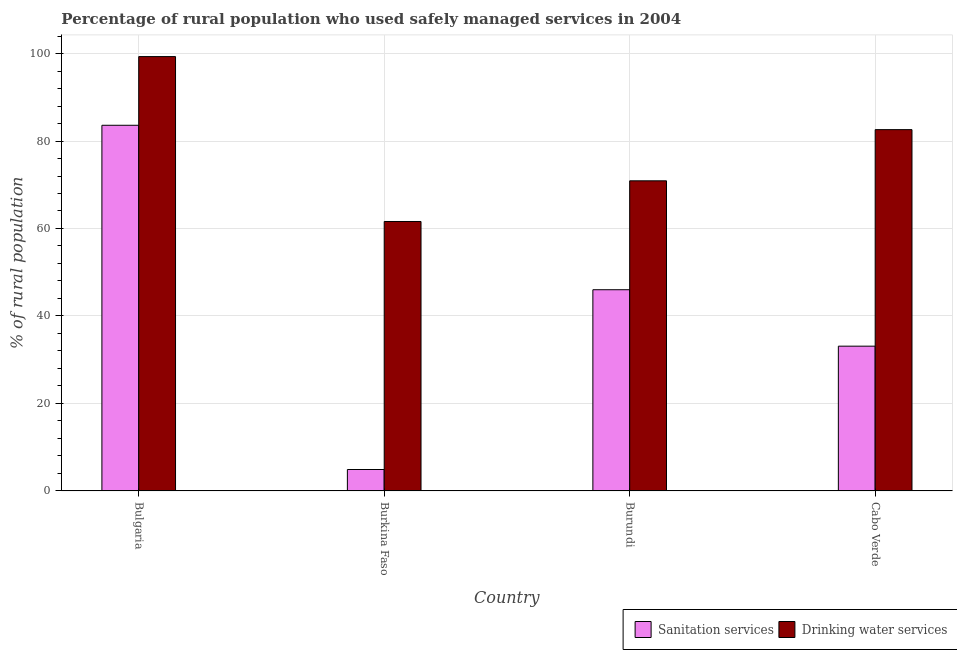How many different coloured bars are there?
Ensure brevity in your answer.  2. Are the number of bars on each tick of the X-axis equal?
Your answer should be compact. Yes. What is the label of the 3rd group of bars from the left?
Your response must be concise. Burundi. In how many cases, is the number of bars for a given country not equal to the number of legend labels?
Ensure brevity in your answer.  0. What is the percentage of rural population who used drinking water services in Bulgaria?
Keep it short and to the point. 99.3. Across all countries, what is the maximum percentage of rural population who used drinking water services?
Your response must be concise. 99.3. Across all countries, what is the minimum percentage of rural population who used drinking water services?
Offer a terse response. 61.6. In which country was the percentage of rural population who used sanitation services minimum?
Offer a very short reply. Burkina Faso. What is the total percentage of rural population who used sanitation services in the graph?
Your answer should be compact. 167.6. What is the difference between the percentage of rural population who used sanitation services in Burkina Faso and that in Cabo Verde?
Make the answer very short. -28.2. What is the difference between the percentage of rural population who used drinking water services in Bulgaria and the percentage of rural population who used sanitation services in Cabo Verde?
Give a very brief answer. 66.2. What is the average percentage of rural population who used drinking water services per country?
Your answer should be compact. 78.6. What is the difference between the percentage of rural population who used sanitation services and percentage of rural population who used drinking water services in Cabo Verde?
Ensure brevity in your answer.  -49.5. In how many countries, is the percentage of rural population who used sanitation services greater than 56 %?
Provide a succinct answer. 1. What is the ratio of the percentage of rural population who used sanitation services in Burkina Faso to that in Burundi?
Provide a short and direct response. 0.11. What is the difference between the highest and the second highest percentage of rural population who used sanitation services?
Offer a terse response. 37.6. What is the difference between the highest and the lowest percentage of rural population who used sanitation services?
Provide a short and direct response. 78.7. In how many countries, is the percentage of rural population who used sanitation services greater than the average percentage of rural population who used sanitation services taken over all countries?
Give a very brief answer. 2. What does the 1st bar from the left in Burundi represents?
Ensure brevity in your answer.  Sanitation services. What does the 2nd bar from the right in Bulgaria represents?
Your answer should be compact. Sanitation services. Are all the bars in the graph horizontal?
Your answer should be very brief. No. What is the difference between two consecutive major ticks on the Y-axis?
Provide a succinct answer. 20. Where does the legend appear in the graph?
Give a very brief answer. Bottom right. How are the legend labels stacked?
Offer a very short reply. Horizontal. What is the title of the graph?
Your response must be concise. Percentage of rural population who used safely managed services in 2004. What is the label or title of the X-axis?
Your answer should be compact. Country. What is the label or title of the Y-axis?
Your response must be concise. % of rural population. What is the % of rural population in Sanitation services in Bulgaria?
Your answer should be compact. 83.6. What is the % of rural population in Drinking water services in Bulgaria?
Provide a short and direct response. 99.3. What is the % of rural population of Sanitation services in Burkina Faso?
Your answer should be very brief. 4.9. What is the % of rural population in Drinking water services in Burkina Faso?
Keep it short and to the point. 61.6. What is the % of rural population of Drinking water services in Burundi?
Your answer should be compact. 70.9. What is the % of rural population of Sanitation services in Cabo Verde?
Offer a very short reply. 33.1. What is the % of rural population of Drinking water services in Cabo Verde?
Give a very brief answer. 82.6. Across all countries, what is the maximum % of rural population of Sanitation services?
Make the answer very short. 83.6. Across all countries, what is the maximum % of rural population of Drinking water services?
Give a very brief answer. 99.3. Across all countries, what is the minimum % of rural population of Sanitation services?
Keep it short and to the point. 4.9. Across all countries, what is the minimum % of rural population of Drinking water services?
Offer a very short reply. 61.6. What is the total % of rural population of Sanitation services in the graph?
Your response must be concise. 167.6. What is the total % of rural population in Drinking water services in the graph?
Offer a very short reply. 314.4. What is the difference between the % of rural population of Sanitation services in Bulgaria and that in Burkina Faso?
Offer a terse response. 78.7. What is the difference between the % of rural population in Drinking water services in Bulgaria and that in Burkina Faso?
Give a very brief answer. 37.7. What is the difference between the % of rural population in Sanitation services in Bulgaria and that in Burundi?
Provide a succinct answer. 37.6. What is the difference between the % of rural population in Drinking water services in Bulgaria and that in Burundi?
Offer a very short reply. 28.4. What is the difference between the % of rural population in Sanitation services in Bulgaria and that in Cabo Verde?
Your answer should be compact. 50.5. What is the difference between the % of rural population of Sanitation services in Burkina Faso and that in Burundi?
Make the answer very short. -41.1. What is the difference between the % of rural population in Sanitation services in Burkina Faso and that in Cabo Verde?
Ensure brevity in your answer.  -28.2. What is the difference between the % of rural population in Sanitation services in Bulgaria and the % of rural population in Drinking water services in Burkina Faso?
Make the answer very short. 22. What is the difference between the % of rural population in Sanitation services in Bulgaria and the % of rural population in Drinking water services in Cabo Verde?
Make the answer very short. 1. What is the difference between the % of rural population of Sanitation services in Burkina Faso and the % of rural population of Drinking water services in Burundi?
Keep it short and to the point. -66. What is the difference between the % of rural population in Sanitation services in Burkina Faso and the % of rural population in Drinking water services in Cabo Verde?
Make the answer very short. -77.7. What is the difference between the % of rural population of Sanitation services in Burundi and the % of rural population of Drinking water services in Cabo Verde?
Keep it short and to the point. -36.6. What is the average % of rural population of Sanitation services per country?
Offer a terse response. 41.9. What is the average % of rural population in Drinking water services per country?
Your response must be concise. 78.6. What is the difference between the % of rural population in Sanitation services and % of rural population in Drinking water services in Bulgaria?
Make the answer very short. -15.7. What is the difference between the % of rural population in Sanitation services and % of rural population in Drinking water services in Burkina Faso?
Your answer should be compact. -56.7. What is the difference between the % of rural population of Sanitation services and % of rural population of Drinking water services in Burundi?
Offer a very short reply. -24.9. What is the difference between the % of rural population in Sanitation services and % of rural population in Drinking water services in Cabo Verde?
Keep it short and to the point. -49.5. What is the ratio of the % of rural population in Sanitation services in Bulgaria to that in Burkina Faso?
Provide a succinct answer. 17.06. What is the ratio of the % of rural population of Drinking water services in Bulgaria to that in Burkina Faso?
Ensure brevity in your answer.  1.61. What is the ratio of the % of rural population in Sanitation services in Bulgaria to that in Burundi?
Make the answer very short. 1.82. What is the ratio of the % of rural population of Drinking water services in Bulgaria to that in Burundi?
Offer a terse response. 1.4. What is the ratio of the % of rural population in Sanitation services in Bulgaria to that in Cabo Verde?
Offer a very short reply. 2.53. What is the ratio of the % of rural population of Drinking water services in Bulgaria to that in Cabo Verde?
Offer a very short reply. 1.2. What is the ratio of the % of rural population in Sanitation services in Burkina Faso to that in Burundi?
Your response must be concise. 0.11. What is the ratio of the % of rural population of Drinking water services in Burkina Faso to that in Burundi?
Provide a succinct answer. 0.87. What is the ratio of the % of rural population in Sanitation services in Burkina Faso to that in Cabo Verde?
Offer a very short reply. 0.15. What is the ratio of the % of rural population in Drinking water services in Burkina Faso to that in Cabo Verde?
Offer a very short reply. 0.75. What is the ratio of the % of rural population of Sanitation services in Burundi to that in Cabo Verde?
Your answer should be compact. 1.39. What is the ratio of the % of rural population in Drinking water services in Burundi to that in Cabo Verde?
Your response must be concise. 0.86. What is the difference between the highest and the second highest % of rural population of Sanitation services?
Provide a short and direct response. 37.6. What is the difference between the highest and the lowest % of rural population of Sanitation services?
Ensure brevity in your answer.  78.7. What is the difference between the highest and the lowest % of rural population of Drinking water services?
Provide a succinct answer. 37.7. 